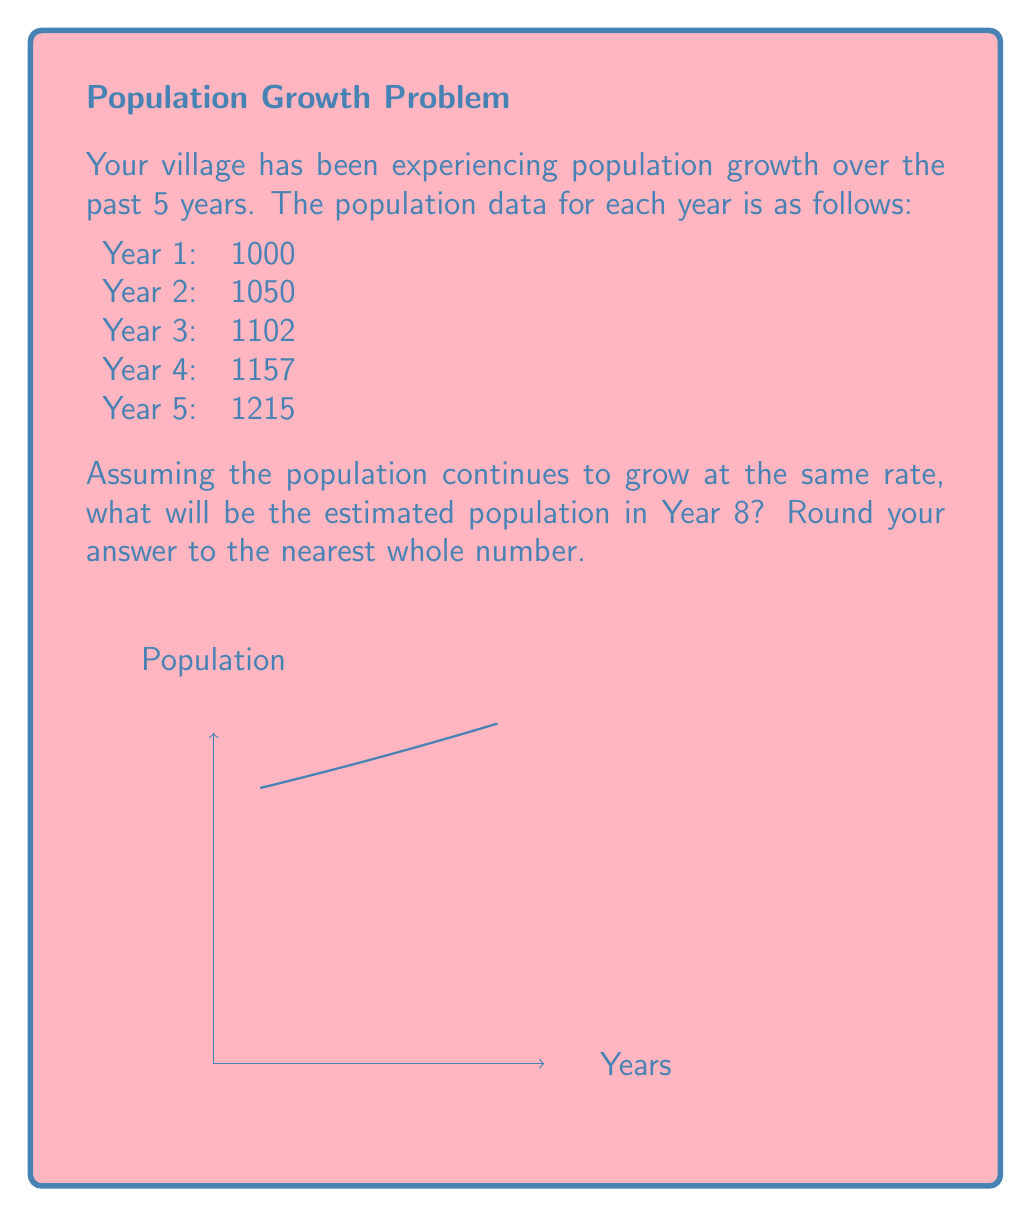Show me your answer to this math problem. To solve this problem, we need to determine the growth rate and then use it to project the population for Year 8. Let's approach this step-by-step:

1) First, we need to calculate the average growth rate. We can do this by finding the year-over-year growth rate and then taking the average.

   Year 1 to 2: $(1050 - 1000) / 1000 = 0.05$ or 5%
   Year 2 to 3: $(1102 - 1050) / 1050 = 0.0495$ or 4.95%
   Year 3 to 4: $(1157 - 1102) / 1102 = 0.0499$ or 4.99%
   Year 4 to 5: $(1215 - 1157) / 1157 = 0.0501$ or 5.01%

2) The average growth rate is:
   $\frac{0.05 + 0.0495 + 0.0499 + 0.0501}{4} = 0.049875$ or approximately 4.99%

3) Now, we can use the compound growth formula to estimate the population in Year 8:
   $P_8 = P_5 * (1 + r)^3$

   Where:
   $P_8$ is the population in Year 8
   $P_5$ is the population in Year 5 (1215)
   $r$ is the growth rate (0.0499)
   3 is the number of years between Year 5 and Year 8

4) Plugging in the values:
   $P_8 = 1215 * (1 + 0.0499)^3$
   $P_8 = 1215 * (1.0499)^3$
   $P_8 = 1215 * 1.1573$
   $P_8 = 1406.12$

5) Rounding to the nearest whole number:
   $P_8 \approx 1406$
Answer: 1406 